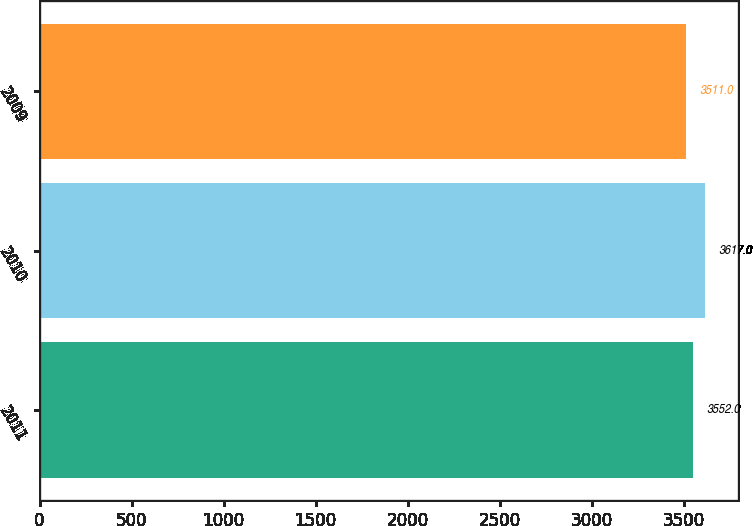Convert chart. <chart><loc_0><loc_0><loc_500><loc_500><bar_chart><fcel>2011<fcel>2010<fcel>2009<nl><fcel>3552<fcel>3617<fcel>3511<nl></chart> 